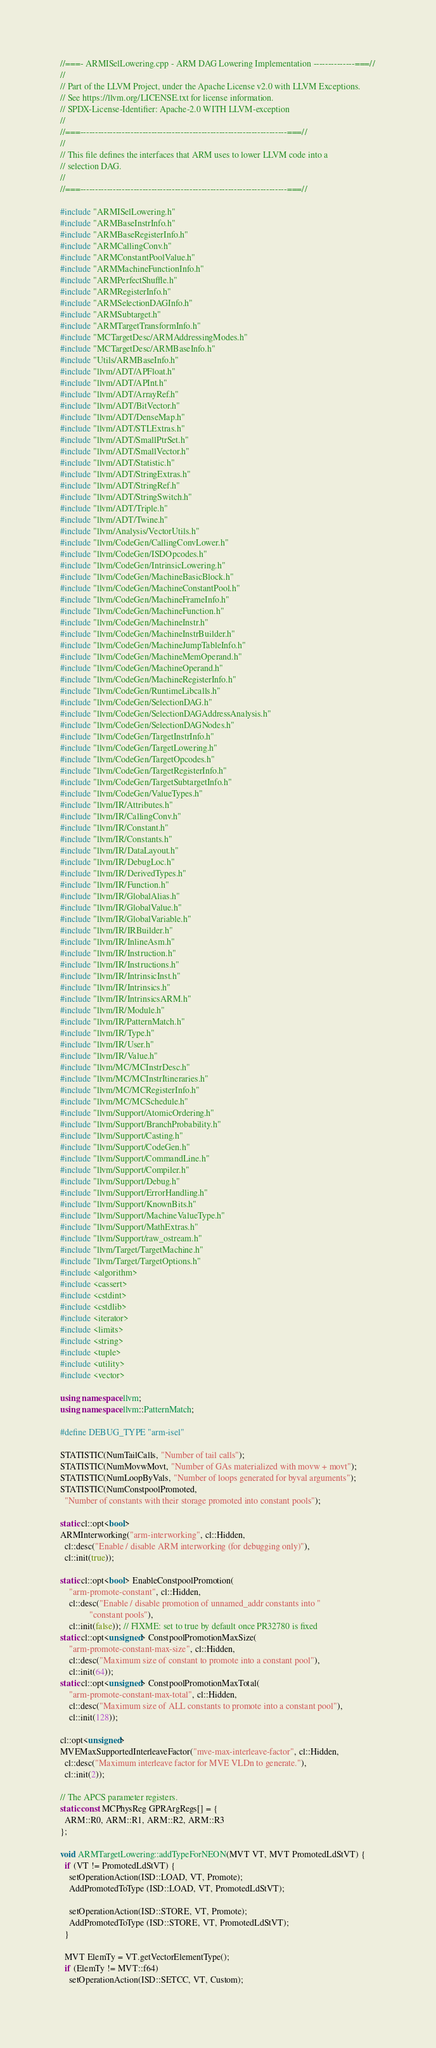<code> <loc_0><loc_0><loc_500><loc_500><_C++_>//===- ARMISelLowering.cpp - ARM DAG Lowering Implementation --------------===//
//
// Part of the LLVM Project, under the Apache License v2.0 with LLVM Exceptions.
// See https://llvm.org/LICENSE.txt for license information.
// SPDX-License-Identifier: Apache-2.0 WITH LLVM-exception
//
//===----------------------------------------------------------------------===//
//
// This file defines the interfaces that ARM uses to lower LLVM code into a
// selection DAG.
//
//===----------------------------------------------------------------------===//

#include "ARMISelLowering.h"
#include "ARMBaseInstrInfo.h"
#include "ARMBaseRegisterInfo.h"
#include "ARMCallingConv.h"
#include "ARMConstantPoolValue.h"
#include "ARMMachineFunctionInfo.h"
#include "ARMPerfectShuffle.h"
#include "ARMRegisterInfo.h"
#include "ARMSelectionDAGInfo.h"
#include "ARMSubtarget.h"
#include "ARMTargetTransformInfo.h"
#include "MCTargetDesc/ARMAddressingModes.h"
#include "MCTargetDesc/ARMBaseInfo.h"
#include "Utils/ARMBaseInfo.h"
#include "llvm/ADT/APFloat.h"
#include "llvm/ADT/APInt.h"
#include "llvm/ADT/ArrayRef.h"
#include "llvm/ADT/BitVector.h"
#include "llvm/ADT/DenseMap.h"
#include "llvm/ADT/STLExtras.h"
#include "llvm/ADT/SmallPtrSet.h"
#include "llvm/ADT/SmallVector.h"
#include "llvm/ADT/Statistic.h"
#include "llvm/ADT/StringExtras.h"
#include "llvm/ADT/StringRef.h"
#include "llvm/ADT/StringSwitch.h"
#include "llvm/ADT/Triple.h"
#include "llvm/ADT/Twine.h"
#include "llvm/Analysis/VectorUtils.h"
#include "llvm/CodeGen/CallingConvLower.h"
#include "llvm/CodeGen/ISDOpcodes.h"
#include "llvm/CodeGen/IntrinsicLowering.h"
#include "llvm/CodeGen/MachineBasicBlock.h"
#include "llvm/CodeGen/MachineConstantPool.h"
#include "llvm/CodeGen/MachineFrameInfo.h"
#include "llvm/CodeGen/MachineFunction.h"
#include "llvm/CodeGen/MachineInstr.h"
#include "llvm/CodeGen/MachineInstrBuilder.h"
#include "llvm/CodeGen/MachineJumpTableInfo.h"
#include "llvm/CodeGen/MachineMemOperand.h"
#include "llvm/CodeGen/MachineOperand.h"
#include "llvm/CodeGen/MachineRegisterInfo.h"
#include "llvm/CodeGen/RuntimeLibcalls.h"
#include "llvm/CodeGen/SelectionDAG.h"
#include "llvm/CodeGen/SelectionDAGAddressAnalysis.h"
#include "llvm/CodeGen/SelectionDAGNodes.h"
#include "llvm/CodeGen/TargetInstrInfo.h"
#include "llvm/CodeGen/TargetLowering.h"
#include "llvm/CodeGen/TargetOpcodes.h"
#include "llvm/CodeGen/TargetRegisterInfo.h"
#include "llvm/CodeGen/TargetSubtargetInfo.h"
#include "llvm/CodeGen/ValueTypes.h"
#include "llvm/IR/Attributes.h"
#include "llvm/IR/CallingConv.h"
#include "llvm/IR/Constant.h"
#include "llvm/IR/Constants.h"
#include "llvm/IR/DataLayout.h"
#include "llvm/IR/DebugLoc.h"
#include "llvm/IR/DerivedTypes.h"
#include "llvm/IR/Function.h"
#include "llvm/IR/GlobalAlias.h"
#include "llvm/IR/GlobalValue.h"
#include "llvm/IR/GlobalVariable.h"
#include "llvm/IR/IRBuilder.h"
#include "llvm/IR/InlineAsm.h"
#include "llvm/IR/Instruction.h"
#include "llvm/IR/Instructions.h"
#include "llvm/IR/IntrinsicInst.h"
#include "llvm/IR/Intrinsics.h"
#include "llvm/IR/IntrinsicsARM.h"
#include "llvm/IR/Module.h"
#include "llvm/IR/PatternMatch.h"
#include "llvm/IR/Type.h"
#include "llvm/IR/User.h"
#include "llvm/IR/Value.h"
#include "llvm/MC/MCInstrDesc.h"
#include "llvm/MC/MCInstrItineraries.h"
#include "llvm/MC/MCRegisterInfo.h"
#include "llvm/MC/MCSchedule.h"
#include "llvm/Support/AtomicOrdering.h"
#include "llvm/Support/BranchProbability.h"
#include "llvm/Support/Casting.h"
#include "llvm/Support/CodeGen.h"
#include "llvm/Support/CommandLine.h"
#include "llvm/Support/Compiler.h"
#include "llvm/Support/Debug.h"
#include "llvm/Support/ErrorHandling.h"
#include "llvm/Support/KnownBits.h"
#include "llvm/Support/MachineValueType.h"
#include "llvm/Support/MathExtras.h"
#include "llvm/Support/raw_ostream.h"
#include "llvm/Target/TargetMachine.h"
#include "llvm/Target/TargetOptions.h"
#include <algorithm>
#include <cassert>
#include <cstdint>
#include <cstdlib>
#include <iterator>
#include <limits>
#include <string>
#include <tuple>
#include <utility>
#include <vector>

using namespace llvm;
using namespace llvm::PatternMatch;

#define DEBUG_TYPE "arm-isel"

STATISTIC(NumTailCalls, "Number of tail calls");
STATISTIC(NumMovwMovt, "Number of GAs materialized with movw + movt");
STATISTIC(NumLoopByVals, "Number of loops generated for byval arguments");
STATISTIC(NumConstpoolPromoted,
  "Number of constants with their storage promoted into constant pools");

static cl::opt<bool>
ARMInterworking("arm-interworking", cl::Hidden,
  cl::desc("Enable / disable ARM interworking (for debugging only)"),
  cl::init(true));

static cl::opt<bool> EnableConstpoolPromotion(
    "arm-promote-constant", cl::Hidden,
    cl::desc("Enable / disable promotion of unnamed_addr constants into "
             "constant pools"),
    cl::init(false)); // FIXME: set to true by default once PR32780 is fixed
static cl::opt<unsigned> ConstpoolPromotionMaxSize(
    "arm-promote-constant-max-size", cl::Hidden,
    cl::desc("Maximum size of constant to promote into a constant pool"),
    cl::init(64));
static cl::opt<unsigned> ConstpoolPromotionMaxTotal(
    "arm-promote-constant-max-total", cl::Hidden,
    cl::desc("Maximum size of ALL constants to promote into a constant pool"),
    cl::init(128));

cl::opt<unsigned>
MVEMaxSupportedInterleaveFactor("mve-max-interleave-factor", cl::Hidden,
  cl::desc("Maximum interleave factor for MVE VLDn to generate."),
  cl::init(2));

// The APCS parameter registers.
static const MCPhysReg GPRArgRegs[] = {
  ARM::R0, ARM::R1, ARM::R2, ARM::R3
};

void ARMTargetLowering::addTypeForNEON(MVT VT, MVT PromotedLdStVT) {
  if (VT != PromotedLdStVT) {
    setOperationAction(ISD::LOAD, VT, Promote);
    AddPromotedToType (ISD::LOAD, VT, PromotedLdStVT);

    setOperationAction(ISD::STORE, VT, Promote);
    AddPromotedToType (ISD::STORE, VT, PromotedLdStVT);
  }

  MVT ElemTy = VT.getVectorElementType();
  if (ElemTy != MVT::f64)
    setOperationAction(ISD::SETCC, VT, Custom);</code> 